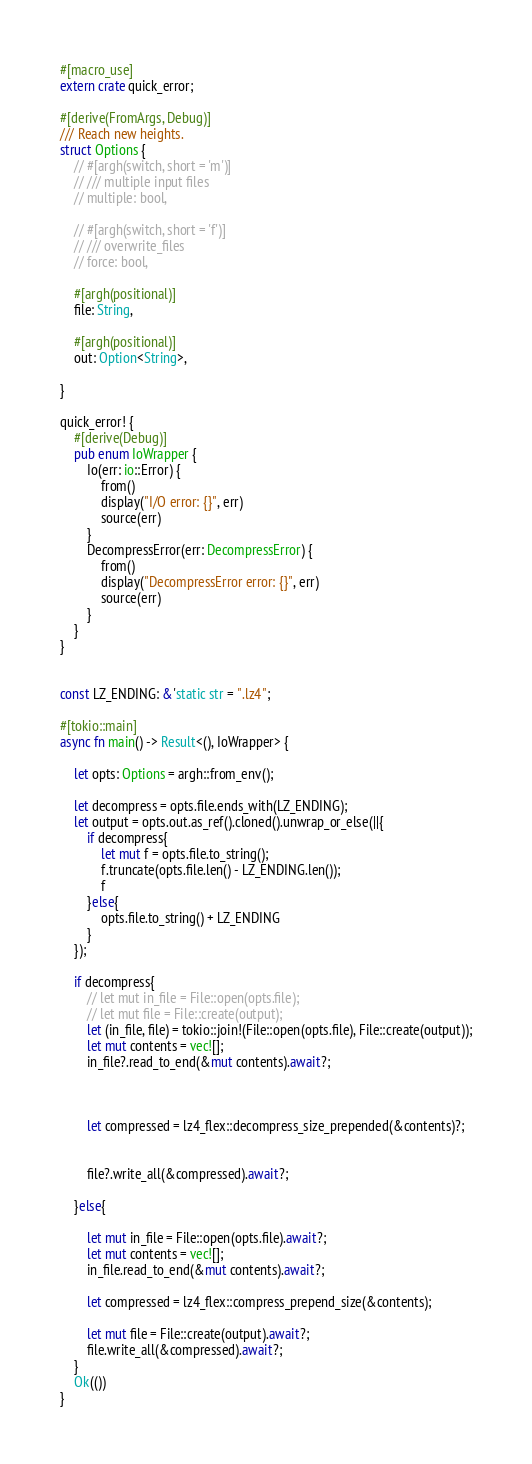<code> <loc_0><loc_0><loc_500><loc_500><_Rust_>
#[macro_use]
extern crate quick_error;

#[derive(FromArgs, Debug)]
/// Reach new heights.
struct Options {
    // #[argh(switch, short = 'm')]
    // /// multiple input files
    // multiple: bool,

    // #[argh(switch, short = 'f')]
    // /// overwrite_files
    // force: bool,

    #[argh(positional)]
    file: String,

    #[argh(positional)]
    out: Option<String>,

}

quick_error! {
    #[derive(Debug)]
    pub enum IoWrapper {
        Io(err: io::Error) {
            from()
            display("I/O error: {}", err)
            source(err)
        }
        DecompressError(err: DecompressError) {
            from()
            display("DecompressError error: {}", err)
            source(err)
        }
    }
}


const LZ_ENDING: &'static str = ".lz4";

#[tokio::main]
async fn main() -> Result<(), IoWrapper> {

    let opts: Options = argh::from_env();

    let decompress = opts.file.ends_with(LZ_ENDING);
    let output = opts.out.as_ref().cloned().unwrap_or_else(||{
        if decompress{
            let mut f = opts.file.to_string();
            f.truncate(opts.file.len() - LZ_ENDING.len());
            f
        }else{
            opts.file.to_string() + LZ_ENDING
        }
    });

    if decompress{
        // let mut in_file = File::open(opts.file);
        // let mut file = File::create(output);
        let (in_file, file) = tokio::join!(File::open(opts.file), File::create(output));
        let mut contents = vec![];
        in_file?.read_to_end(&mut contents).await?;

        

        let compressed = lz4_flex::decompress_size_prepended(&contents)?;

        
        file?.write_all(&compressed).await?;

    }else{

        let mut in_file = File::open(opts.file).await?;
        let mut contents = vec![];
        in_file.read_to_end(&mut contents).await?;

        let compressed = lz4_flex::compress_prepend_size(&contents);

        let mut file = File::create(output).await?;
        file.write_all(&compressed).await?;
    }
    Ok(())
}


</code> 